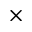<formula> <loc_0><loc_0><loc_500><loc_500>\times</formula> 